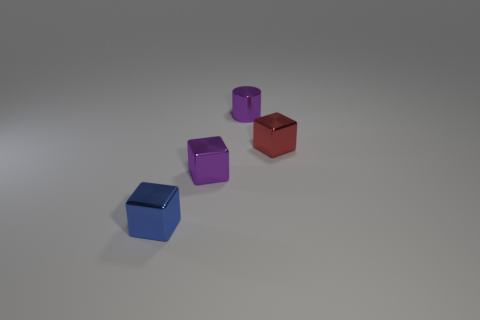What is the material of the purple cube?
Your answer should be very brief. Metal. Are there any shiny cubes that are in front of the tiny purple shiny thing that is in front of the metallic cube that is right of the tiny purple cylinder?
Your answer should be compact. Yes. The small metal cylinder is what color?
Keep it short and to the point. Purple. Are there any tiny purple metal cubes on the right side of the blue metal object?
Give a very brief answer. Yes. Do the red metal object and the tiny purple metallic object that is to the left of the metallic cylinder have the same shape?
Offer a very short reply. Yes. What is the color of the small metallic cube that is in front of the tiny purple thing to the left of the purple metallic object right of the purple metal cube?
Give a very brief answer. Blue. There is a tiny purple metallic object that is in front of the small block that is to the right of the tiny purple metallic cylinder; what is its shape?
Your answer should be very brief. Cube. Is the number of tiny metal blocks behind the small blue metallic block greater than the number of cyan balls?
Offer a terse response. Yes. There is a tiny purple thing behind the tiny red block; is it the same shape as the tiny red metallic object?
Your response must be concise. No. Are there any tiny blue metallic things of the same shape as the tiny red shiny thing?
Provide a succinct answer. Yes. 